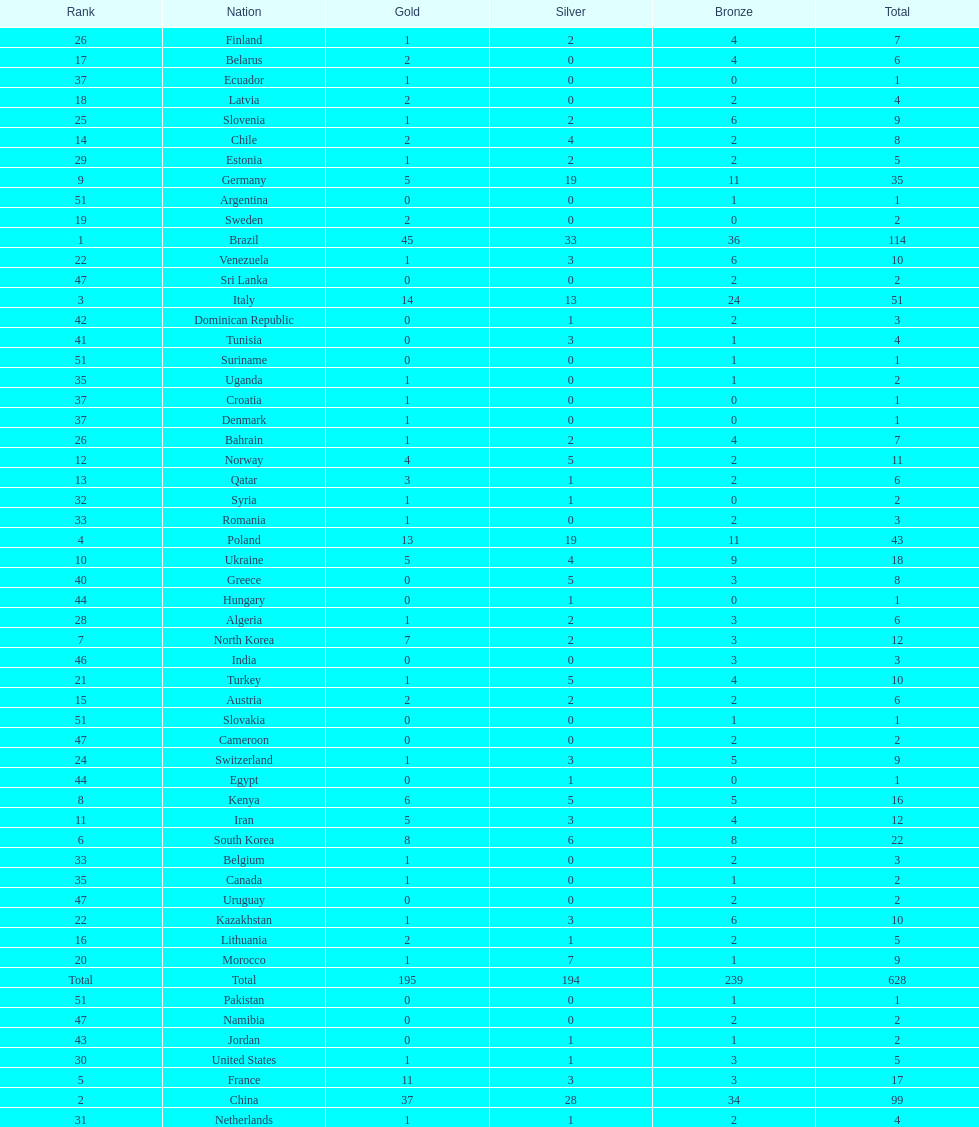Who won more gold medals, brazil or china? Brazil. Could you parse the entire table as a dict? {'header': ['Rank', 'Nation', 'Gold', 'Silver', 'Bronze', 'Total'], 'rows': [['26', 'Finland', '1', '2', '4', '7'], ['17', 'Belarus', '2', '0', '4', '6'], ['37', 'Ecuador', '1', '0', '0', '1'], ['18', 'Latvia', '2', '0', '2', '4'], ['25', 'Slovenia', '1', '2', '6', '9'], ['14', 'Chile', '2', '4', '2', '8'], ['29', 'Estonia', '1', '2', '2', '5'], ['9', 'Germany', '5', '19', '11', '35'], ['51', 'Argentina', '0', '0', '1', '1'], ['19', 'Sweden', '2', '0', '0', '2'], ['1', 'Brazil', '45', '33', '36', '114'], ['22', 'Venezuela', '1', '3', '6', '10'], ['47', 'Sri Lanka', '0', '0', '2', '2'], ['3', 'Italy', '14', '13', '24', '51'], ['42', 'Dominican Republic', '0', '1', '2', '3'], ['41', 'Tunisia', '0', '3', '1', '4'], ['51', 'Suriname', '0', '0', '1', '1'], ['35', 'Uganda', '1', '0', '1', '2'], ['37', 'Croatia', '1', '0', '0', '1'], ['37', 'Denmark', '1', '0', '0', '1'], ['26', 'Bahrain', '1', '2', '4', '7'], ['12', 'Norway', '4', '5', '2', '11'], ['13', 'Qatar', '3', '1', '2', '6'], ['32', 'Syria', '1', '1', '0', '2'], ['33', 'Romania', '1', '0', '2', '3'], ['4', 'Poland', '13', '19', '11', '43'], ['10', 'Ukraine', '5', '4', '9', '18'], ['40', 'Greece', '0', '5', '3', '8'], ['44', 'Hungary', '0', '1', '0', '1'], ['28', 'Algeria', '1', '2', '3', '6'], ['7', 'North Korea', '7', '2', '3', '12'], ['46', 'India', '0', '0', '3', '3'], ['21', 'Turkey', '1', '5', '4', '10'], ['15', 'Austria', '2', '2', '2', '6'], ['51', 'Slovakia', '0', '0', '1', '1'], ['47', 'Cameroon', '0', '0', '2', '2'], ['24', 'Switzerland', '1', '3', '5', '9'], ['44', 'Egypt', '0', '1', '0', '1'], ['8', 'Kenya', '6', '5', '5', '16'], ['11', 'Iran', '5', '3', '4', '12'], ['6', 'South Korea', '8', '6', '8', '22'], ['33', 'Belgium', '1', '0', '2', '3'], ['35', 'Canada', '1', '0', '1', '2'], ['47', 'Uruguay', '0', '0', '2', '2'], ['22', 'Kazakhstan', '1', '3', '6', '10'], ['16', 'Lithuania', '2', '1', '2', '5'], ['20', 'Morocco', '1', '7', '1', '9'], ['Total', 'Total', '195', '194', '239', '628'], ['51', 'Pakistan', '0', '0', '1', '1'], ['47', 'Namibia', '0', '0', '2', '2'], ['43', 'Jordan', '0', '1', '1', '2'], ['30', 'United States', '1', '1', '3', '5'], ['5', 'France', '11', '3', '3', '17'], ['2', 'China', '37', '28', '34', '99'], ['31', 'Netherlands', '1', '1', '2', '4']]} 